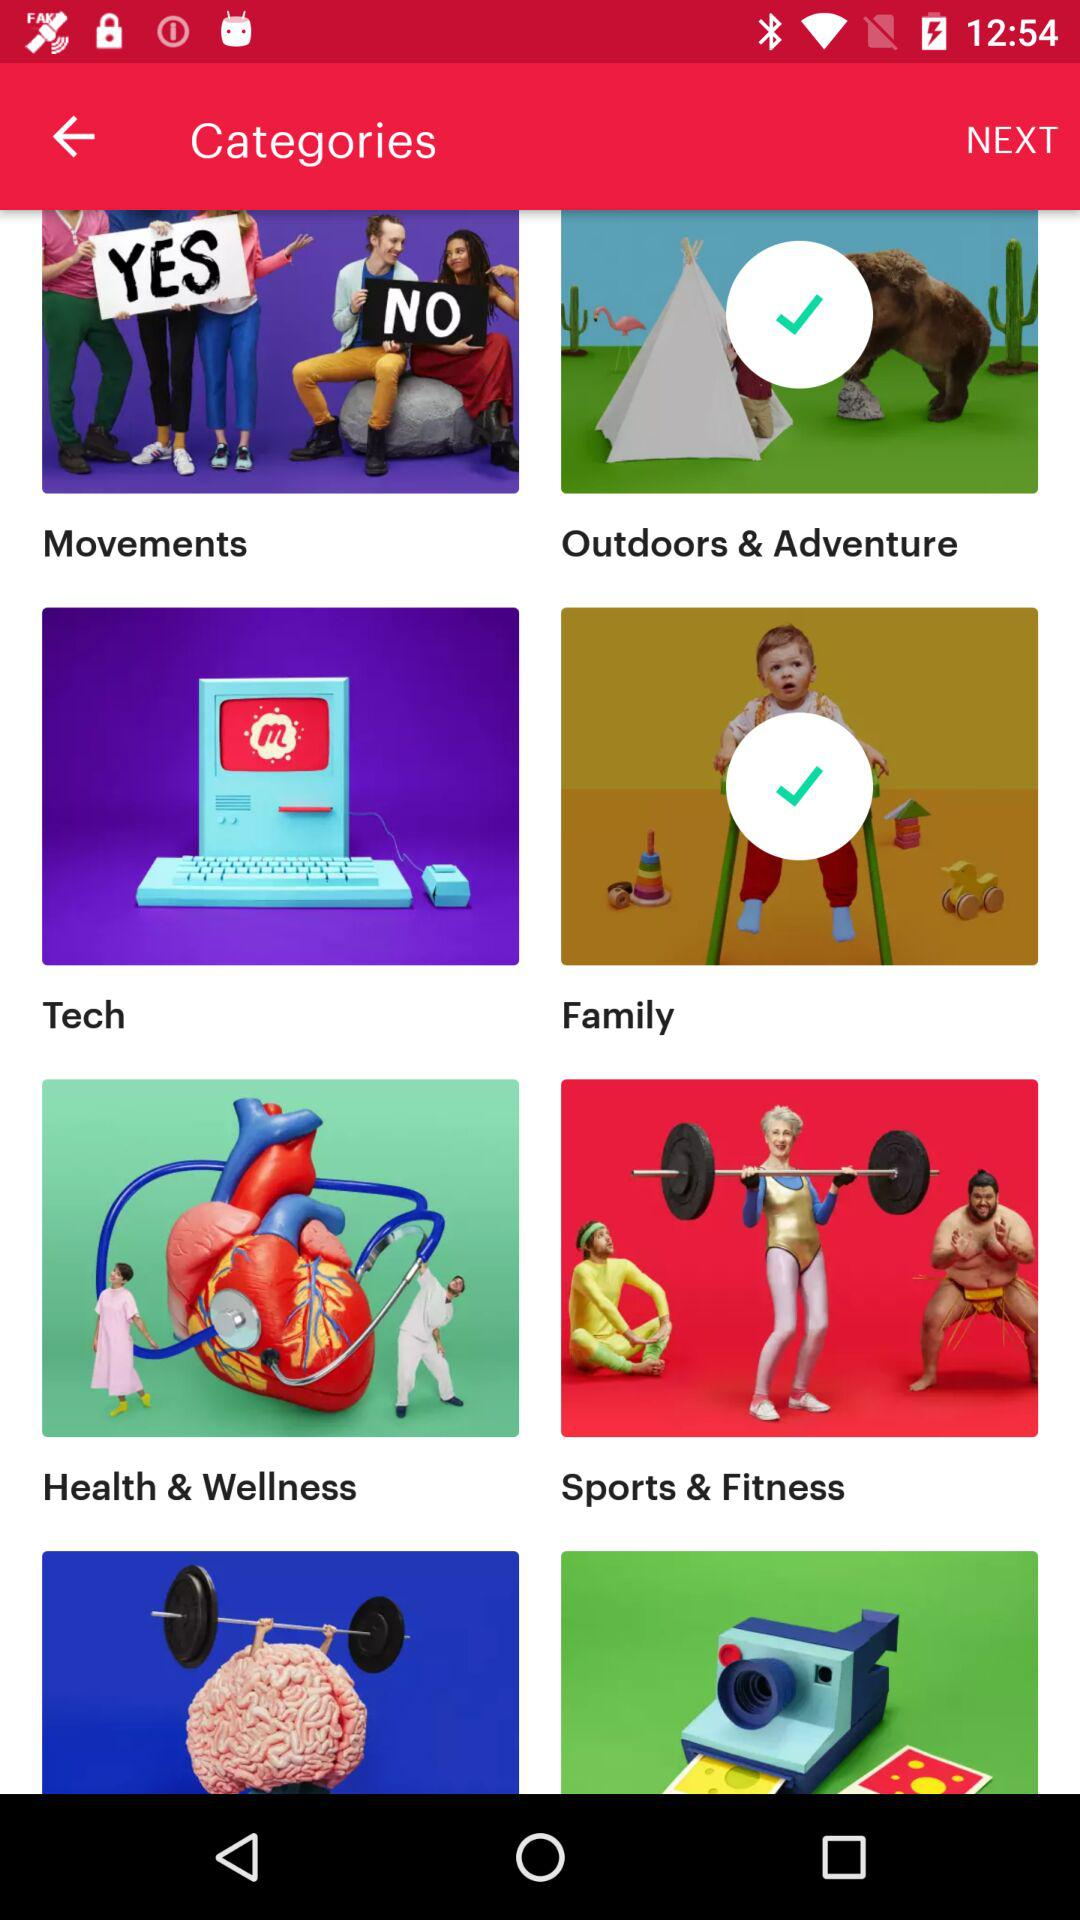Which are the selected categories? The selected categories are "Outdoors & Adventure" and "Family". 